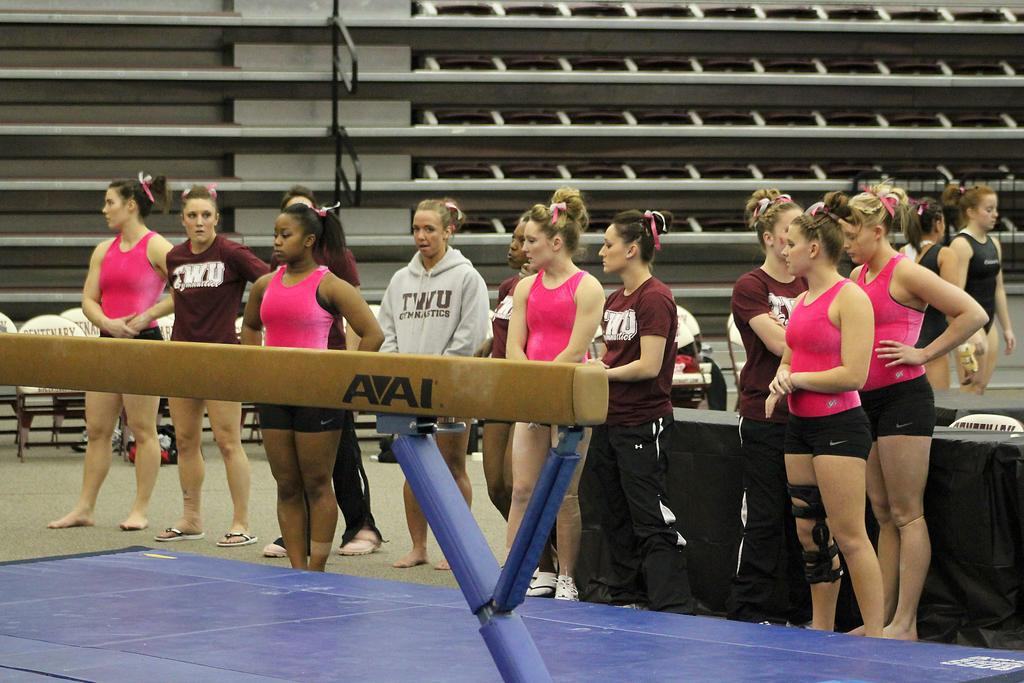Who or what can be seen in the image? There are people in the image. What type of furniture is present in the image? There are chairs and tables in the image. Is there a veil covering the people in the image? No, there is no veil present in the image. What type of action are the people performing in the image? The provided facts do not mention any specific actions being performed by the people in the image. 